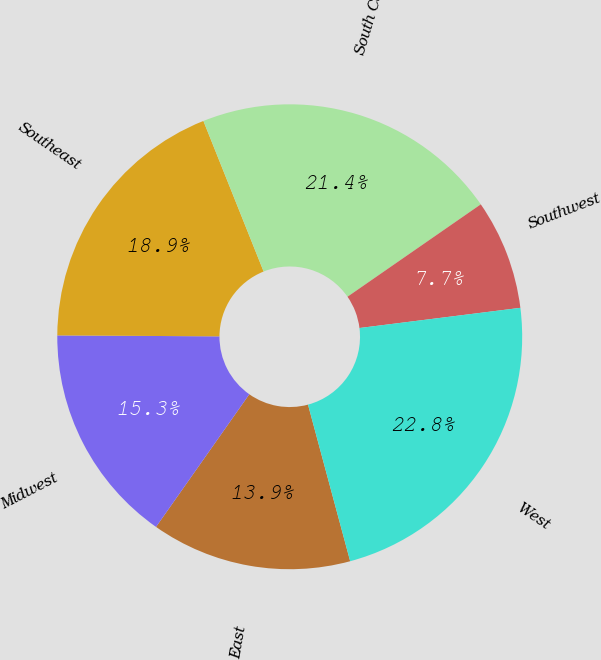Convert chart to OTSL. <chart><loc_0><loc_0><loc_500><loc_500><pie_chart><fcel>East<fcel>Midwest<fcel>Southeast<fcel>South Central<fcel>Southwest<fcel>West<nl><fcel>13.94%<fcel>15.34%<fcel>18.85%<fcel>21.41%<fcel>7.66%<fcel>22.8%<nl></chart> 